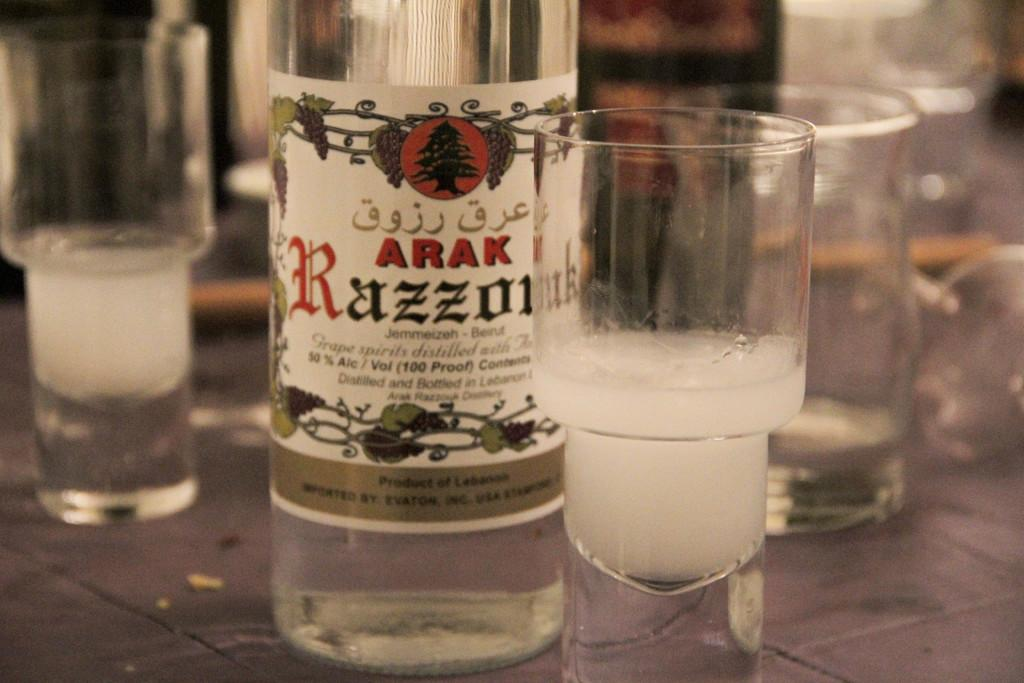<image>
Give a short and clear explanation of the subsequent image. A bottle of alcohol called "Arak Razzonuk" sits on the table. 